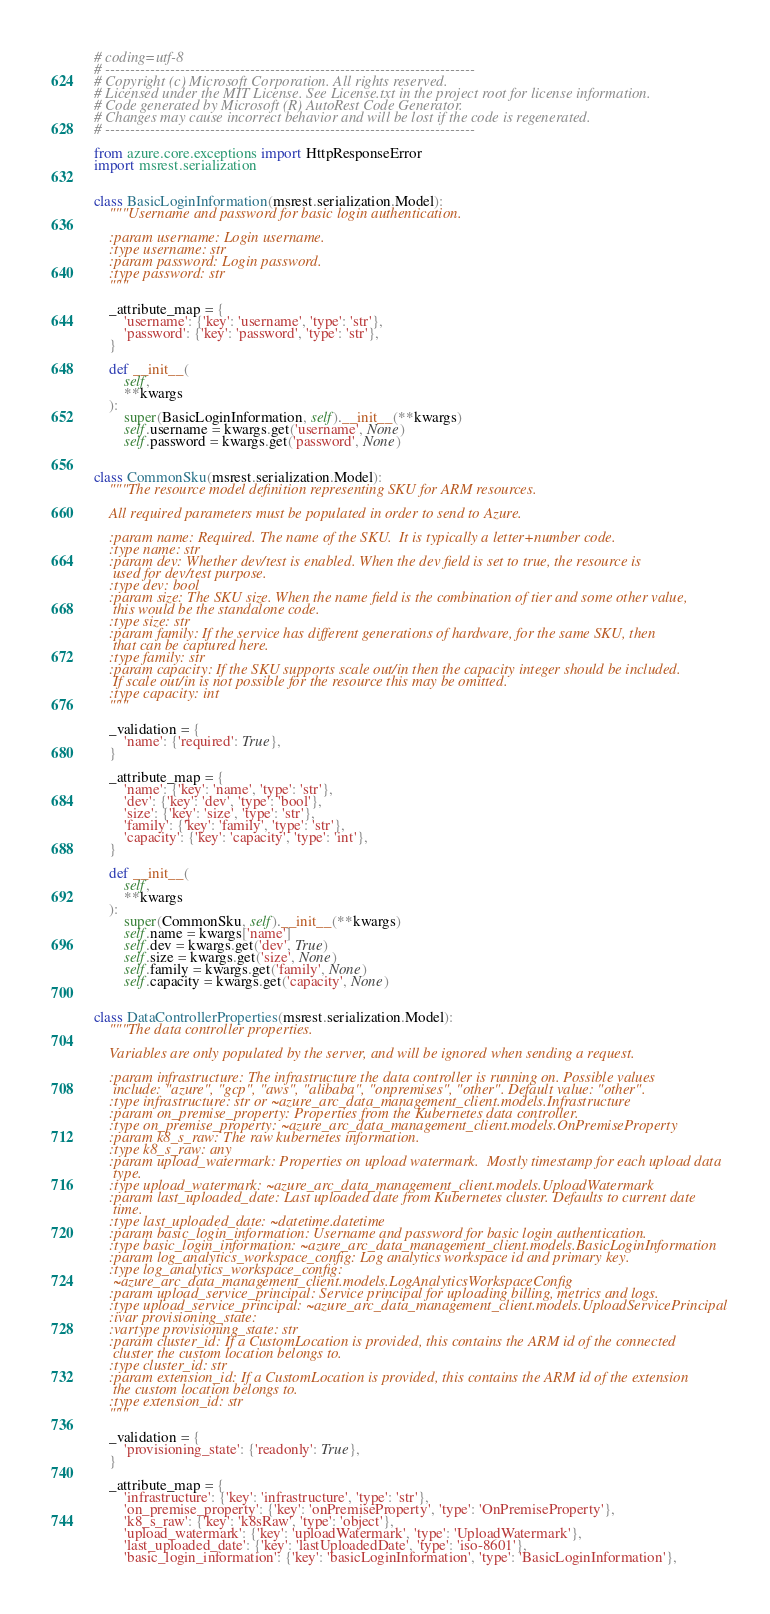<code> <loc_0><loc_0><loc_500><loc_500><_Python_># coding=utf-8
# --------------------------------------------------------------------------
# Copyright (c) Microsoft Corporation. All rights reserved.
# Licensed under the MIT License. See License.txt in the project root for license information.
# Code generated by Microsoft (R) AutoRest Code Generator.
# Changes may cause incorrect behavior and will be lost if the code is regenerated.
# --------------------------------------------------------------------------

from azure.core.exceptions import HttpResponseError
import msrest.serialization


class BasicLoginInformation(msrest.serialization.Model):
    """Username and password for basic login authentication.

    :param username: Login username.
    :type username: str
    :param password: Login password.
    :type password: str
    """

    _attribute_map = {
        'username': {'key': 'username', 'type': 'str'},
        'password': {'key': 'password', 'type': 'str'},
    }

    def __init__(
        self,
        **kwargs
    ):
        super(BasicLoginInformation, self).__init__(**kwargs)
        self.username = kwargs.get('username', None)
        self.password = kwargs.get('password', None)


class CommonSku(msrest.serialization.Model):
    """The resource model definition representing SKU for ARM resources.

    All required parameters must be populated in order to send to Azure.

    :param name: Required. The name of the SKU.  It is typically a letter+number code.
    :type name: str
    :param dev: Whether dev/test is enabled. When the dev field is set to true, the resource is
     used for dev/test purpose.
    :type dev: bool
    :param size: The SKU size. When the name field is the combination of tier and some other value,
     this would be the standalone code.
    :type size: str
    :param family: If the service has different generations of hardware, for the same SKU, then
     that can be captured here.
    :type family: str
    :param capacity: If the SKU supports scale out/in then the capacity integer should be included.
     If scale out/in is not possible for the resource this may be omitted.
    :type capacity: int
    """

    _validation = {
        'name': {'required': True},
    }

    _attribute_map = {
        'name': {'key': 'name', 'type': 'str'},
        'dev': {'key': 'dev', 'type': 'bool'},
        'size': {'key': 'size', 'type': 'str'},
        'family': {'key': 'family', 'type': 'str'},
        'capacity': {'key': 'capacity', 'type': 'int'},
    }

    def __init__(
        self,
        **kwargs
    ):
        super(CommonSku, self).__init__(**kwargs)
        self.name = kwargs['name']
        self.dev = kwargs.get('dev', True)
        self.size = kwargs.get('size', None)
        self.family = kwargs.get('family', None)
        self.capacity = kwargs.get('capacity', None)


class DataControllerProperties(msrest.serialization.Model):
    """The data controller properties.

    Variables are only populated by the server, and will be ignored when sending a request.

    :param infrastructure: The infrastructure the data controller is running on. Possible values
     include: "azure", "gcp", "aws", "alibaba", "onpremises", "other". Default value: "other".
    :type infrastructure: str or ~azure_arc_data_management_client.models.Infrastructure
    :param on_premise_property: Properties from the Kubernetes data controller.
    :type on_premise_property: ~azure_arc_data_management_client.models.OnPremiseProperty
    :param k8_s_raw: The raw kubernetes information.
    :type k8_s_raw: any
    :param upload_watermark: Properties on upload watermark.  Mostly timestamp for each upload data
     type.
    :type upload_watermark: ~azure_arc_data_management_client.models.UploadWatermark
    :param last_uploaded_date: Last uploaded date from Kubernetes cluster. Defaults to current date
     time.
    :type last_uploaded_date: ~datetime.datetime
    :param basic_login_information: Username and password for basic login authentication.
    :type basic_login_information: ~azure_arc_data_management_client.models.BasicLoginInformation
    :param log_analytics_workspace_config: Log analytics workspace id and primary key.
    :type log_analytics_workspace_config:
     ~azure_arc_data_management_client.models.LogAnalyticsWorkspaceConfig
    :param upload_service_principal: Service principal for uploading billing, metrics and logs.
    :type upload_service_principal: ~azure_arc_data_management_client.models.UploadServicePrincipal
    :ivar provisioning_state:
    :vartype provisioning_state: str
    :param cluster_id: If a CustomLocation is provided, this contains the ARM id of the connected
     cluster the custom location belongs to.
    :type cluster_id: str
    :param extension_id: If a CustomLocation is provided, this contains the ARM id of the extension
     the custom location belongs to.
    :type extension_id: str
    """

    _validation = {
        'provisioning_state': {'readonly': True},
    }

    _attribute_map = {
        'infrastructure': {'key': 'infrastructure', 'type': 'str'},
        'on_premise_property': {'key': 'onPremiseProperty', 'type': 'OnPremiseProperty'},
        'k8_s_raw': {'key': 'k8sRaw', 'type': 'object'},
        'upload_watermark': {'key': 'uploadWatermark', 'type': 'UploadWatermark'},
        'last_uploaded_date': {'key': 'lastUploadedDate', 'type': 'iso-8601'},
        'basic_login_information': {'key': 'basicLoginInformation', 'type': 'BasicLoginInformation'},</code> 